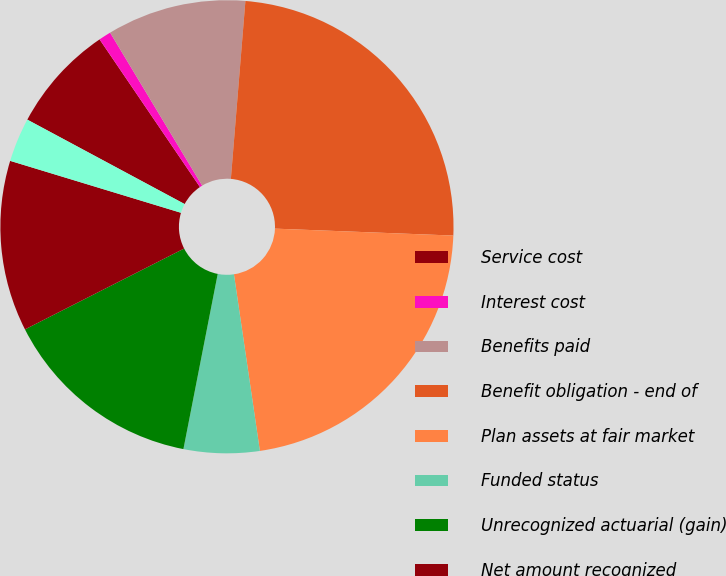Convert chart. <chart><loc_0><loc_0><loc_500><loc_500><pie_chart><fcel>Service cost<fcel>Interest cost<fcel>Benefits paid<fcel>Benefit obligation - end of<fcel>Plan assets at fair market<fcel>Funded status<fcel>Unrecognized actuarial (gain)<fcel>Net amount recognized<fcel>Accrued benefit liability<nl><fcel>7.66%<fcel>0.88%<fcel>9.92%<fcel>24.32%<fcel>22.06%<fcel>5.4%<fcel>14.44%<fcel>12.18%<fcel>3.14%<nl></chart> 